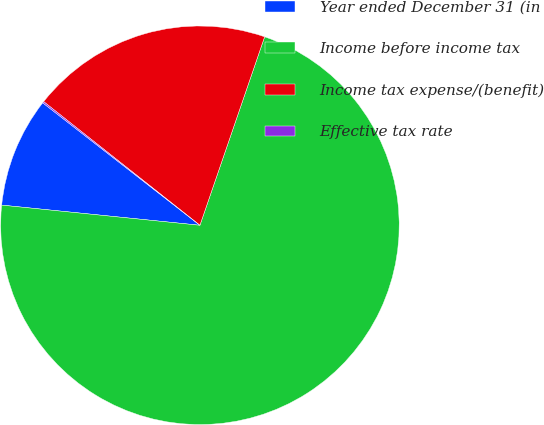Convert chart to OTSL. <chart><loc_0><loc_0><loc_500><loc_500><pie_chart><fcel>Year ended December 31 (in<fcel>Income before income tax<fcel>Income tax expense/(benefit)<fcel>Effective tax rate<nl><fcel>8.92%<fcel>71.35%<fcel>19.61%<fcel>0.12%<nl></chart> 